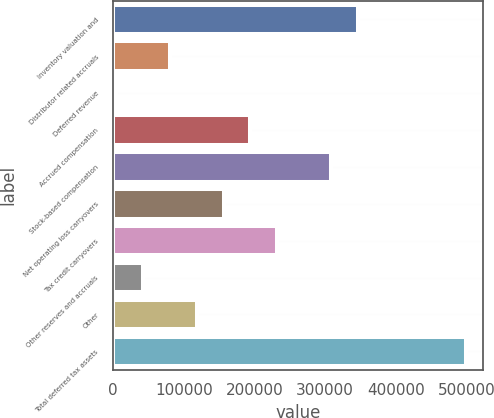Convert chart. <chart><loc_0><loc_0><loc_500><loc_500><bar_chart><fcel>Inventory valuation and<fcel>Distributor related accruals<fcel>Deferred revenue<fcel>Accrued compensation<fcel>Stock-based compensation<fcel>Net operating loss carryovers<fcel>Tax credit carryovers<fcel>Other reserves and accruals<fcel>Other<fcel>Total deferred tax assets<nl><fcel>346667<fcel>80264.8<fcel>4150<fcel>194437<fcel>308609<fcel>156380<fcel>232494<fcel>42207.4<fcel>118322<fcel>498896<nl></chart> 